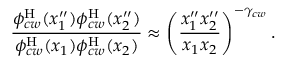Convert formula to latex. <formula><loc_0><loc_0><loc_500><loc_500>\frac { \phi _ { c w } ^ { H } ( x _ { 1 } ^ { \prime \prime } ) \phi _ { c w } ^ { H } ( x _ { 2 } ^ { \prime \prime } ) } { \phi _ { c w } ^ { H } ( x _ { 1 } ) \phi _ { c w } ^ { H } ( x _ { 2 } ) } \approx \left ( \frac { x _ { 1 } ^ { \prime \prime } x _ { 2 } ^ { \prime \prime } } { x _ { 1 } x _ { 2 } } \right ) ^ { - \gamma _ { c w } } .</formula> 